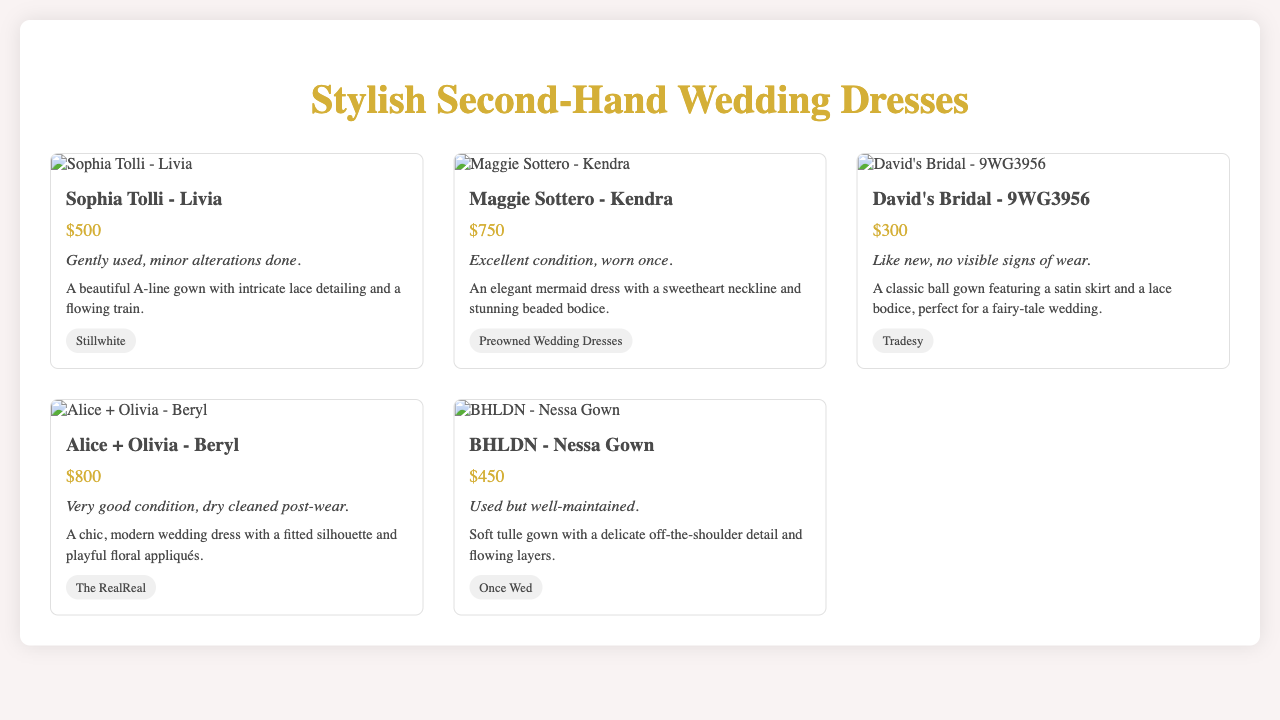what is the price of the Sophia Tolli dress? The price of the Sophia Tolli dress is listed in the document.
Answer: $500 what is the condition of the Maggie Sottero dress? The condition of the Maggie Sottero dress is specified in the document.
Answer: Excellent condition, worn once which retailer is selling the David's Bridal dress? The retailer for the David's Bridal dress is mentioned in the document.
Answer: Tradesy how many different wedding dresses are displayed? The total number of wedding dresses is calculable from the document.
Answer: 5 which dress has the highest price? The highest-priced dress is determined by comparing all prices in the document.
Answer: Alice + Olivia - Beryl what type of neckline does the Maggie Sottero dress have? The neckline type for the Maggie Sottero dress is included in the dress description.
Answer: Sweetheart neckline what is the main feature of the David's Bridal dress? The primary characteristic of the David's Bridal dress is pinpointed in the description.
Answer: Classic ball gown which dress was dry cleaned post-wear? The document mentions if any dress was dry cleaned after it was worn.
Answer: Alice + Olivia - Beryl 